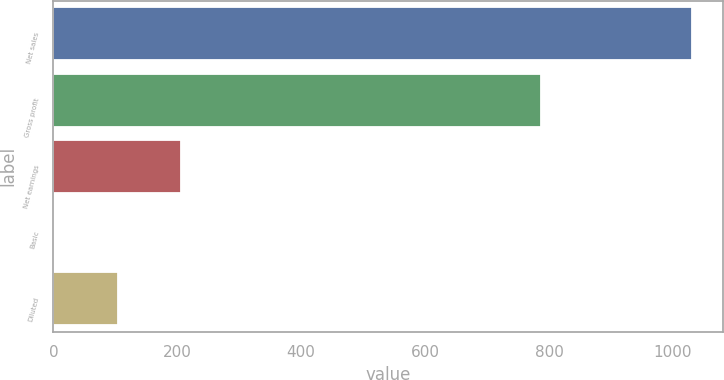Convert chart to OTSL. <chart><loc_0><loc_0><loc_500><loc_500><bar_chart><fcel>Net sales<fcel>Gross profit<fcel>Net earnings<fcel>Basic<fcel>Diluted<nl><fcel>1030.2<fcel>787.1<fcel>206.65<fcel>0.75<fcel>103.7<nl></chart> 